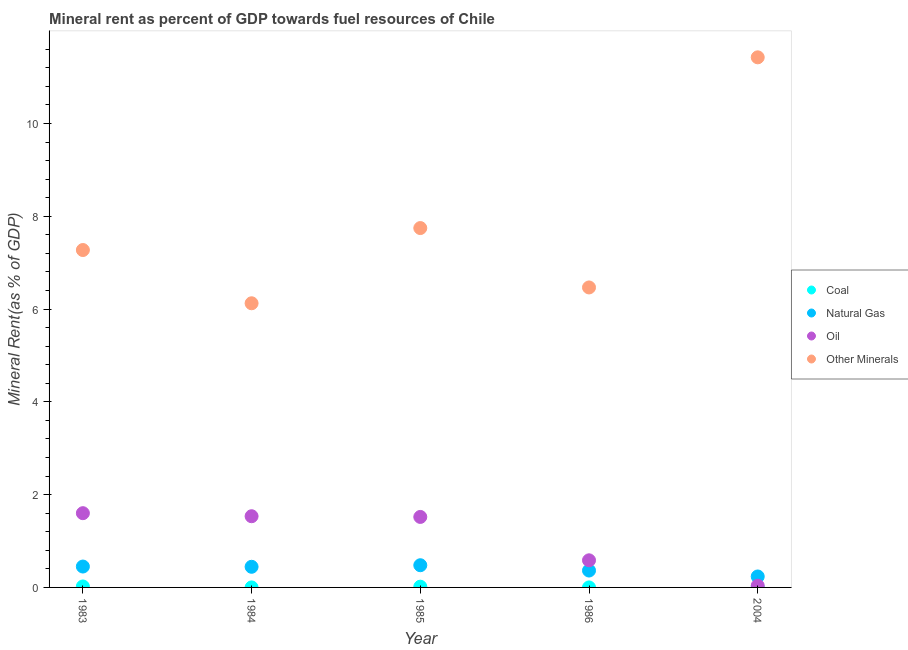What is the  rent of other minerals in 1984?
Your response must be concise. 6.12. Across all years, what is the maximum oil rent?
Offer a terse response. 1.6. Across all years, what is the minimum natural gas rent?
Your answer should be very brief. 0.24. In which year was the coal rent minimum?
Your answer should be very brief. 1986. What is the total oil rent in the graph?
Your answer should be very brief. 5.28. What is the difference between the natural gas rent in 1983 and that in 1985?
Your answer should be compact. -0.03. What is the difference between the oil rent in 1986 and the natural gas rent in 1984?
Make the answer very short. 0.14. What is the average oil rent per year?
Provide a succinct answer. 1.06. In the year 2004, what is the difference between the oil rent and coal rent?
Make the answer very short. 0.04. In how many years, is the  rent of other minerals greater than 10.4 %?
Ensure brevity in your answer.  1. What is the ratio of the oil rent in 1984 to that in 1986?
Your response must be concise. 2.63. Is the difference between the  rent of other minerals in 1983 and 1985 greater than the difference between the oil rent in 1983 and 1985?
Ensure brevity in your answer.  No. What is the difference between the highest and the second highest natural gas rent?
Your answer should be compact. 0.03. What is the difference between the highest and the lowest natural gas rent?
Give a very brief answer. 0.24. In how many years, is the oil rent greater than the average oil rent taken over all years?
Offer a very short reply. 3. Is the sum of the  rent of other minerals in 1985 and 1986 greater than the maximum coal rent across all years?
Provide a succinct answer. Yes. Is it the case that in every year, the sum of the  rent of other minerals and oil rent is greater than the sum of coal rent and natural gas rent?
Provide a succinct answer. Yes. Is it the case that in every year, the sum of the coal rent and natural gas rent is greater than the oil rent?
Ensure brevity in your answer.  No. Does the natural gas rent monotonically increase over the years?
Make the answer very short. No. Is the coal rent strictly less than the  rent of other minerals over the years?
Keep it short and to the point. Yes. How many years are there in the graph?
Keep it short and to the point. 5. What is the difference between two consecutive major ticks on the Y-axis?
Give a very brief answer. 2. How many legend labels are there?
Offer a very short reply. 4. What is the title of the graph?
Your answer should be compact. Mineral rent as percent of GDP towards fuel resources of Chile. Does "Quality of logistic services" appear as one of the legend labels in the graph?
Give a very brief answer. No. What is the label or title of the Y-axis?
Your response must be concise. Mineral Rent(as % of GDP). What is the Mineral Rent(as % of GDP) in Coal in 1983?
Provide a succinct answer. 0.02. What is the Mineral Rent(as % of GDP) of Natural Gas in 1983?
Your answer should be compact. 0.45. What is the Mineral Rent(as % of GDP) of Oil in 1983?
Offer a terse response. 1.6. What is the Mineral Rent(as % of GDP) in Other Minerals in 1983?
Your answer should be very brief. 7.27. What is the Mineral Rent(as % of GDP) of Coal in 1984?
Ensure brevity in your answer.  0. What is the Mineral Rent(as % of GDP) in Natural Gas in 1984?
Your answer should be compact. 0.44. What is the Mineral Rent(as % of GDP) of Oil in 1984?
Offer a terse response. 1.53. What is the Mineral Rent(as % of GDP) of Other Minerals in 1984?
Offer a very short reply. 6.12. What is the Mineral Rent(as % of GDP) in Coal in 1985?
Your response must be concise. 0.02. What is the Mineral Rent(as % of GDP) in Natural Gas in 1985?
Give a very brief answer. 0.48. What is the Mineral Rent(as % of GDP) of Oil in 1985?
Your answer should be compact. 1.52. What is the Mineral Rent(as % of GDP) of Other Minerals in 1985?
Offer a very short reply. 7.75. What is the Mineral Rent(as % of GDP) of Coal in 1986?
Provide a short and direct response. 0. What is the Mineral Rent(as % of GDP) in Natural Gas in 1986?
Your answer should be very brief. 0.36. What is the Mineral Rent(as % of GDP) of Oil in 1986?
Provide a succinct answer. 0.58. What is the Mineral Rent(as % of GDP) of Other Minerals in 1986?
Your answer should be very brief. 6.47. What is the Mineral Rent(as % of GDP) of Coal in 2004?
Offer a terse response. 0. What is the Mineral Rent(as % of GDP) of Natural Gas in 2004?
Your answer should be compact. 0.24. What is the Mineral Rent(as % of GDP) of Oil in 2004?
Give a very brief answer. 0.04. What is the Mineral Rent(as % of GDP) of Other Minerals in 2004?
Your answer should be very brief. 11.43. Across all years, what is the maximum Mineral Rent(as % of GDP) of Coal?
Offer a very short reply. 0.02. Across all years, what is the maximum Mineral Rent(as % of GDP) in Natural Gas?
Your answer should be very brief. 0.48. Across all years, what is the maximum Mineral Rent(as % of GDP) in Oil?
Provide a succinct answer. 1.6. Across all years, what is the maximum Mineral Rent(as % of GDP) in Other Minerals?
Make the answer very short. 11.43. Across all years, what is the minimum Mineral Rent(as % of GDP) in Coal?
Your answer should be compact. 0. Across all years, what is the minimum Mineral Rent(as % of GDP) of Natural Gas?
Keep it short and to the point. 0.24. Across all years, what is the minimum Mineral Rent(as % of GDP) in Oil?
Give a very brief answer. 0.04. Across all years, what is the minimum Mineral Rent(as % of GDP) in Other Minerals?
Make the answer very short. 6.12. What is the total Mineral Rent(as % of GDP) in Coal in the graph?
Give a very brief answer. 0.04. What is the total Mineral Rent(as % of GDP) of Natural Gas in the graph?
Offer a very short reply. 1.97. What is the total Mineral Rent(as % of GDP) in Oil in the graph?
Your response must be concise. 5.28. What is the total Mineral Rent(as % of GDP) in Other Minerals in the graph?
Offer a very short reply. 39.04. What is the difference between the Mineral Rent(as % of GDP) in Coal in 1983 and that in 1984?
Provide a succinct answer. 0.02. What is the difference between the Mineral Rent(as % of GDP) in Natural Gas in 1983 and that in 1984?
Make the answer very short. 0.01. What is the difference between the Mineral Rent(as % of GDP) of Oil in 1983 and that in 1984?
Your response must be concise. 0.07. What is the difference between the Mineral Rent(as % of GDP) in Other Minerals in 1983 and that in 1984?
Provide a succinct answer. 1.15. What is the difference between the Mineral Rent(as % of GDP) in Coal in 1983 and that in 1985?
Make the answer very short. 0. What is the difference between the Mineral Rent(as % of GDP) in Natural Gas in 1983 and that in 1985?
Make the answer very short. -0.03. What is the difference between the Mineral Rent(as % of GDP) in Oil in 1983 and that in 1985?
Offer a very short reply. 0.08. What is the difference between the Mineral Rent(as % of GDP) of Other Minerals in 1983 and that in 1985?
Keep it short and to the point. -0.47. What is the difference between the Mineral Rent(as % of GDP) in Coal in 1983 and that in 1986?
Make the answer very short. 0.02. What is the difference between the Mineral Rent(as % of GDP) of Natural Gas in 1983 and that in 1986?
Your answer should be very brief. 0.09. What is the difference between the Mineral Rent(as % of GDP) of Oil in 1983 and that in 1986?
Offer a terse response. 1.02. What is the difference between the Mineral Rent(as % of GDP) of Other Minerals in 1983 and that in 1986?
Ensure brevity in your answer.  0.81. What is the difference between the Mineral Rent(as % of GDP) in Coal in 1983 and that in 2004?
Provide a short and direct response. 0.02. What is the difference between the Mineral Rent(as % of GDP) of Natural Gas in 1983 and that in 2004?
Make the answer very short. 0.21. What is the difference between the Mineral Rent(as % of GDP) of Oil in 1983 and that in 2004?
Offer a very short reply. 1.56. What is the difference between the Mineral Rent(as % of GDP) of Other Minerals in 1983 and that in 2004?
Provide a short and direct response. -4.15. What is the difference between the Mineral Rent(as % of GDP) in Coal in 1984 and that in 1985?
Offer a very short reply. -0.02. What is the difference between the Mineral Rent(as % of GDP) in Natural Gas in 1984 and that in 1985?
Offer a very short reply. -0.03. What is the difference between the Mineral Rent(as % of GDP) in Oil in 1984 and that in 1985?
Make the answer very short. 0.01. What is the difference between the Mineral Rent(as % of GDP) of Other Minerals in 1984 and that in 1985?
Give a very brief answer. -1.62. What is the difference between the Mineral Rent(as % of GDP) of Coal in 1984 and that in 1986?
Offer a very short reply. 0. What is the difference between the Mineral Rent(as % of GDP) of Natural Gas in 1984 and that in 1986?
Offer a very short reply. 0.08. What is the difference between the Mineral Rent(as % of GDP) in Oil in 1984 and that in 1986?
Your response must be concise. 0.95. What is the difference between the Mineral Rent(as % of GDP) in Other Minerals in 1984 and that in 1986?
Your answer should be compact. -0.34. What is the difference between the Mineral Rent(as % of GDP) of Coal in 1984 and that in 2004?
Provide a short and direct response. -0. What is the difference between the Mineral Rent(as % of GDP) of Natural Gas in 1984 and that in 2004?
Your answer should be compact. 0.21. What is the difference between the Mineral Rent(as % of GDP) of Oil in 1984 and that in 2004?
Keep it short and to the point. 1.5. What is the difference between the Mineral Rent(as % of GDP) of Other Minerals in 1984 and that in 2004?
Your answer should be very brief. -5.3. What is the difference between the Mineral Rent(as % of GDP) in Coal in 1985 and that in 1986?
Keep it short and to the point. 0.02. What is the difference between the Mineral Rent(as % of GDP) in Natural Gas in 1985 and that in 1986?
Give a very brief answer. 0.11. What is the difference between the Mineral Rent(as % of GDP) in Oil in 1985 and that in 1986?
Your response must be concise. 0.94. What is the difference between the Mineral Rent(as % of GDP) of Other Minerals in 1985 and that in 1986?
Keep it short and to the point. 1.28. What is the difference between the Mineral Rent(as % of GDP) in Coal in 1985 and that in 2004?
Provide a succinct answer. 0.01. What is the difference between the Mineral Rent(as % of GDP) in Natural Gas in 1985 and that in 2004?
Your answer should be very brief. 0.24. What is the difference between the Mineral Rent(as % of GDP) in Oil in 1985 and that in 2004?
Offer a very short reply. 1.48. What is the difference between the Mineral Rent(as % of GDP) in Other Minerals in 1985 and that in 2004?
Your answer should be very brief. -3.68. What is the difference between the Mineral Rent(as % of GDP) of Coal in 1986 and that in 2004?
Your response must be concise. -0. What is the difference between the Mineral Rent(as % of GDP) of Natural Gas in 1986 and that in 2004?
Your response must be concise. 0.13. What is the difference between the Mineral Rent(as % of GDP) of Oil in 1986 and that in 2004?
Provide a succinct answer. 0.55. What is the difference between the Mineral Rent(as % of GDP) in Other Minerals in 1986 and that in 2004?
Give a very brief answer. -4.96. What is the difference between the Mineral Rent(as % of GDP) in Coal in 1983 and the Mineral Rent(as % of GDP) in Natural Gas in 1984?
Ensure brevity in your answer.  -0.42. What is the difference between the Mineral Rent(as % of GDP) in Coal in 1983 and the Mineral Rent(as % of GDP) in Oil in 1984?
Ensure brevity in your answer.  -1.51. What is the difference between the Mineral Rent(as % of GDP) of Coal in 1983 and the Mineral Rent(as % of GDP) of Other Minerals in 1984?
Offer a terse response. -6.1. What is the difference between the Mineral Rent(as % of GDP) in Natural Gas in 1983 and the Mineral Rent(as % of GDP) in Oil in 1984?
Your answer should be very brief. -1.08. What is the difference between the Mineral Rent(as % of GDP) in Natural Gas in 1983 and the Mineral Rent(as % of GDP) in Other Minerals in 1984?
Keep it short and to the point. -5.67. What is the difference between the Mineral Rent(as % of GDP) of Oil in 1983 and the Mineral Rent(as % of GDP) of Other Minerals in 1984?
Provide a succinct answer. -4.52. What is the difference between the Mineral Rent(as % of GDP) in Coal in 1983 and the Mineral Rent(as % of GDP) in Natural Gas in 1985?
Offer a terse response. -0.46. What is the difference between the Mineral Rent(as % of GDP) of Coal in 1983 and the Mineral Rent(as % of GDP) of Oil in 1985?
Make the answer very short. -1.5. What is the difference between the Mineral Rent(as % of GDP) in Coal in 1983 and the Mineral Rent(as % of GDP) in Other Minerals in 1985?
Give a very brief answer. -7.73. What is the difference between the Mineral Rent(as % of GDP) of Natural Gas in 1983 and the Mineral Rent(as % of GDP) of Oil in 1985?
Make the answer very short. -1.07. What is the difference between the Mineral Rent(as % of GDP) of Natural Gas in 1983 and the Mineral Rent(as % of GDP) of Other Minerals in 1985?
Offer a very short reply. -7.3. What is the difference between the Mineral Rent(as % of GDP) of Oil in 1983 and the Mineral Rent(as % of GDP) of Other Minerals in 1985?
Keep it short and to the point. -6.15. What is the difference between the Mineral Rent(as % of GDP) of Coal in 1983 and the Mineral Rent(as % of GDP) of Natural Gas in 1986?
Ensure brevity in your answer.  -0.34. What is the difference between the Mineral Rent(as % of GDP) in Coal in 1983 and the Mineral Rent(as % of GDP) in Oil in 1986?
Offer a terse response. -0.56. What is the difference between the Mineral Rent(as % of GDP) in Coal in 1983 and the Mineral Rent(as % of GDP) in Other Minerals in 1986?
Give a very brief answer. -6.45. What is the difference between the Mineral Rent(as % of GDP) of Natural Gas in 1983 and the Mineral Rent(as % of GDP) of Oil in 1986?
Your answer should be very brief. -0.13. What is the difference between the Mineral Rent(as % of GDP) of Natural Gas in 1983 and the Mineral Rent(as % of GDP) of Other Minerals in 1986?
Your answer should be compact. -6.02. What is the difference between the Mineral Rent(as % of GDP) of Oil in 1983 and the Mineral Rent(as % of GDP) of Other Minerals in 1986?
Provide a succinct answer. -4.87. What is the difference between the Mineral Rent(as % of GDP) of Coal in 1983 and the Mineral Rent(as % of GDP) of Natural Gas in 2004?
Your response must be concise. -0.22. What is the difference between the Mineral Rent(as % of GDP) in Coal in 1983 and the Mineral Rent(as % of GDP) in Oil in 2004?
Keep it short and to the point. -0.02. What is the difference between the Mineral Rent(as % of GDP) of Coal in 1983 and the Mineral Rent(as % of GDP) of Other Minerals in 2004?
Give a very brief answer. -11.41. What is the difference between the Mineral Rent(as % of GDP) of Natural Gas in 1983 and the Mineral Rent(as % of GDP) of Oil in 2004?
Make the answer very short. 0.41. What is the difference between the Mineral Rent(as % of GDP) of Natural Gas in 1983 and the Mineral Rent(as % of GDP) of Other Minerals in 2004?
Make the answer very short. -10.98. What is the difference between the Mineral Rent(as % of GDP) of Oil in 1983 and the Mineral Rent(as % of GDP) of Other Minerals in 2004?
Your answer should be very brief. -9.83. What is the difference between the Mineral Rent(as % of GDP) in Coal in 1984 and the Mineral Rent(as % of GDP) in Natural Gas in 1985?
Give a very brief answer. -0.48. What is the difference between the Mineral Rent(as % of GDP) in Coal in 1984 and the Mineral Rent(as % of GDP) in Oil in 1985?
Make the answer very short. -1.52. What is the difference between the Mineral Rent(as % of GDP) in Coal in 1984 and the Mineral Rent(as % of GDP) in Other Minerals in 1985?
Offer a very short reply. -7.75. What is the difference between the Mineral Rent(as % of GDP) of Natural Gas in 1984 and the Mineral Rent(as % of GDP) of Oil in 1985?
Your response must be concise. -1.07. What is the difference between the Mineral Rent(as % of GDP) of Natural Gas in 1984 and the Mineral Rent(as % of GDP) of Other Minerals in 1985?
Your answer should be compact. -7.3. What is the difference between the Mineral Rent(as % of GDP) of Oil in 1984 and the Mineral Rent(as % of GDP) of Other Minerals in 1985?
Offer a terse response. -6.21. What is the difference between the Mineral Rent(as % of GDP) in Coal in 1984 and the Mineral Rent(as % of GDP) in Natural Gas in 1986?
Provide a succinct answer. -0.36. What is the difference between the Mineral Rent(as % of GDP) of Coal in 1984 and the Mineral Rent(as % of GDP) of Oil in 1986?
Your response must be concise. -0.58. What is the difference between the Mineral Rent(as % of GDP) of Coal in 1984 and the Mineral Rent(as % of GDP) of Other Minerals in 1986?
Your answer should be very brief. -6.47. What is the difference between the Mineral Rent(as % of GDP) in Natural Gas in 1984 and the Mineral Rent(as % of GDP) in Oil in 1986?
Offer a terse response. -0.14. What is the difference between the Mineral Rent(as % of GDP) of Natural Gas in 1984 and the Mineral Rent(as % of GDP) of Other Minerals in 1986?
Offer a terse response. -6.02. What is the difference between the Mineral Rent(as % of GDP) of Oil in 1984 and the Mineral Rent(as % of GDP) of Other Minerals in 1986?
Offer a very short reply. -4.93. What is the difference between the Mineral Rent(as % of GDP) of Coal in 1984 and the Mineral Rent(as % of GDP) of Natural Gas in 2004?
Offer a very short reply. -0.24. What is the difference between the Mineral Rent(as % of GDP) of Coal in 1984 and the Mineral Rent(as % of GDP) of Oil in 2004?
Provide a succinct answer. -0.04. What is the difference between the Mineral Rent(as % of GDP) of Coal in 1984 and the Mineral Rent(as % of GDP) of Other Minerals in 2004?
Provide a succinct answer. -11.43. What is the difference between the Mineral Rent(as % of GDP) in Natural Gas in 1984 and the Mineral Rent(as % of GDP) in Oil in 2004?
Keep it short and to the point. 0.41. What is the difference between the Mineral Rent(as % of GDP) of Natural Gas in 1984 and the Mineral Rent(as % of GDP) of Other Minerals in 2004?
Keep it short and to the point. -10.98. What is the difference between the Mineral Rent(as % of GDP) of Oil in 1984 and the Mineral Rent(as % of GDP) of Other Minerals in 2004?
Offer a very short reply. -9.89. What is the difference between the Mineral Rent(as % of GDP) in Coal in 1985 and the Mineral Rent(as % of GDP) in Natural Gas in 1986?
Offer a terse response. -0.35. What is the difference between the Mineral Rent(as % of GDP) of Coal in 1985 and the Mineral Rent(as % of GDP) of Oil in 1986?
Make the answer very short. -0.57. What is the difference between the Mineral Rent(as % of GDP) in Coal in 1985 and the Mineral Rent(as % of GDP) in Other Minerals in 1986?
Your response must be concise. -6.45. What is the difference between the Mineral Rent(as % of GDP) in Natural Gas in 1985 and the Mineral Rent(as % of GDP) in Oil in 1986?
Your answer should be compact. -0.11. What is the difference between the Mineral Rent(as % of GDP) in Natural Gas in 1985 and the Mineral Rent(as % of GDP) in Other Minerals in 1986?
Your answer should be compact. -5.99. What is the difference between the Mineral Rent(as % of GDP) in Oil in 1985 and the Mineral Rent(as % of GDP) in Other Minerals in 1986?
Keep it short and to the point. -4.95. What is the difference between the Mineral Rent(as % of GDP) in Coal in 1985 and the Mineral Rent(as % of GDP) in Natural Gas in 2004?
Offer a very short reply. -0.22. What is the difference between the Mineral Rent(as % of GDP) in Coal in 1985 and the Mineral Rent(as % of GDP) in Oil in 2004?
Make the answer very short. -0.02. What is the difference between the Mineral Rent(as % of GDP) in Coal in 1985 and the Mineral Rent(as % of GDP) in Other Minerals in 2004?
Offer a terse response. -11.41. What is the difference between the Mineral Rent(as % of GDP) in Natural Gas in 1985 and the Mineral Rent(as % of GDP) in Oil in 2004?
Make the answer very short. 0.44. What is the difference between the Mineral Rent(as % of GDP) of Natural Gas in 1985 and the Mineral Rent(as % of GDP) of Other Minerals in 2004?
Provide a succinct answer. -10.95. What is the difference between the Mineral Rent(as % of GDP) of Oil in 1985 and the Mineral Rent(as % of GDP) of Other Minerals in 2004?
Provide a succinct answer. -9.91. What is the difference between the Mineral Rent(as % of GDP) of Coal in 1986 and the Mineral Rent(as % of GDP) of Natural Gas in 2004?
Offer a very short reply. -0.24. What is the difference between the Mineral Rent(as % of GDP) of Coal in 1986 and the Mineral Rent(as % of GDP) of Oil in 2004?
Provide a short and direct response. -0.04. What is the difference between the Mineral Rent(as % of GDP) of Coal in 1986 and the Mineral Rent(as % of GDP) of Other Minerals in 2004?
Keep it short and to the point. -11.43. What is the difference between the Mineral Rent(as % of GDP) of Natural Gas in 1986 and the Mineral Rent(as % of GDP) of Oil in 2004?
Ensure brevity in your answer.  0.33. What is the difference between the Mineral Rent(as % of GDP) in Natural Gas in 1986 and the Mineral Rent(as % of GDP) in Other Minerals in 2004?
Provide a short and direct response. -11.06. What is the difference between the Mineral Rent(as % of GDP) of Oil in 1986 and the Mineral Rent(as % of GDP) of Other Minerals in 2004?
Give a very brief answer. -10.84. What is the average Mineral Rent(as % of GDP) of Coal per year?
Make the answer very short. 0.01. What is the average Mineral Rent(as % of GDP) in Natural Gas per year?
Offer a terse response. 0.39. What is the average Mineral Rent(as % of GDP) of Oil per year?
Your answer should be very brief. 1.06. What is the average Mineral Rent(as % of GDP) in Other Minerals per year?
Give a very brief answer. 7.81. In the year 1983, what is the difference between the Mineral Rent(as % of GDP) in Coal and Mineral Rent(as % of GDP) in Natural Gas?
Provide a succinct answer. -0.43. In the year 1983, what is the difference between the Mineral Rent(as % of GDP) in Coal and Mineral Rent(as % of GDP) in Oil?
Keep it short and to the point. -1.58. In the year 1983, what is the difference between the Mineral Rent(as % of GDP) of Coal and Mineral Rent(as % of GDP) of Other Minerals?
Your answer should be very brief. -7.25. In the year 1983, what is the difference between the Mineral Rent(as % of GDP) of Natural Gas and Mineral Rent(as % of GDP) of Oil?
Your answer should be very brief. -1.15. In the year 1983, what is the difference between the Mineral Rent(as % of GDP) in Natural Gas and Mineral Rent(as % of GDP) in Other Minerals?
Offer a very short reply. -6.82. In the year 1983, what is the difference between the Mineral Rent(as % of GDP) of Oil and Mineral Rent(as % of GDP) of Other Minerals?
Your response must be concise. -5.67. In the year 1984, what is the difference between the Mineral Rent(as % of GDP) in Coal and Mineral Rent(as % of GDP) in Natural Gas?
Provide a short and direct response. -0.44. In the year 1984, what is the difference between the Mineral Rent(as % of GDP) in Coal and Mineral Rent(as % of GDP) in Oil?
Keep it short and to the point. -1.53. In the year 1984, what is the difference between the Mineral Rent(as % of GDP) in Coal and Mineral Rent(as % of GDP) in Other Minerals?
Ensure brevity in your answer.  -6.12. In the year 1984, what is the difference between the Mineral Rent(as % of GDP) in Natural Gas and Mineral Rent(as % of GDP) in Oil?
Offer a very short reply. -1.09. In the year 1984, what is the difference between the Mineral Rent(as % of GDP) of Natural Gas and Mineral Rent(as % of GDP) of Other Minerals?
Keep it short and to the point. -5.68. In the year 1984, what is the difference between the Mineral Rent(as % of GDP) in Oil and Mineral Rent(as % of GDP) in Other Minerals?
Offer a very short reply. -4.59. In the year 1985, what is the difference between the Mineral Rent(as % of GDP) in Coal and Mineral Rent(as % of GDP) in Natural Gas?
Your answer should be compact. -0.46. In the year 1985, what is the difference between the Mineral Rent(as % of GDP) in Coal and Mineral Rent(as % of GDP) in Oil?
Provide a short and direct response. -1.5. In the year 1985, what is the difference between the Mineral Rent(as % of GDP) of Coal and Mineral Rent(as % of GDP) of Other Minerals?
Keep it short and to the point. -7.73. In the year 1985, what is the difference between the Mineral Rent(as % of GDP) in Natural Gas and Mineral Rent(as % of GDP) in Oil?
Ensure brevity in your answer.  -1.04. In the year 1985, what is the difference between the Mineral Rent(as % of GDP) in Natural Gas and Mineral Rent(as % of GDP) in Other Minerals?
Provide a succinct answer. -7.27. In the year 1985, what is the difference between the Mineral Rent(as % of GDP) in Oil and Mineral Rent(as % of GDP) in Other Minerals?
Ensure brevity in your answer.  -6.23. In the year 1986, what is the difference between the Mineral Rent(as % of GDP) in Coal and Mineral Rent(as % of GDP) in Natural Gas?
Offer a very short reply. -0.36. In the year 1986, what is the difference between the Mineral Rent(as % of GDP) in Coal and Mineral Rent(as % of GDP) in Oil?
Provide a short and direct response. -0.58. In the year 1986, what is the difference between the Mineral Rent(as % of GDP) of Coal and Mineral Rent(as % of GDP) of Other Minerals?
Offer a very short reply. -6.47. In the year 1986, what is the difference between the Mineral Rent(as % of GDP) in Natural Gas and Mineral Rent(as % of GDP) in Oil?
Your answer should be very brief. -0.22. In the year 1986, what is the difference between the Mineral Rent(as % of GDP) in Natural Gas and Mineral Rent(as % of GDP) in Other Minerals?
Offer a terse response. -6.1. In the year 1986, what is the difference between the Mineral Rent(as % of GDP) in Oil and Mineral Rent(as % of GDP) in Other Minerals?
Provide a short and direct response. -5.88. In the year 2004, what is the difference between the Mineral Rent(as % of GDP) of Coal and Mineral Rent(as % of GDP) of Natural Gas?
Offer a terse response. -0.23. In the year 2004, what is the difference between the Mineral Rent(as % of GDP) of Coal and Mineral Rent(as % of GDP) of Oil?
Your answer should be very brief. -0.04. In the year 2004, what is the difference between the Mineral Rent(as % of GDP) of Coal and Mineral Rent(as % of GDP) of Other Minerals?
Ensure brevity in your answer.  -11.42. In the year 2004, what is the difference between the Mineral Rent(as % of GDP) of Natural Gas and Mineral Rent(as % of GDP) of Oil?
Offer a very short reply. 0.2. In the year 2004, what is the difference between the Mineral Rent(as % of GDP) of Natural Gas and Mineral Rent(as % of GDP) of Other Minerals?
Your answer should be compact. -11.19. In the year 2004, what is the difference between the Mineral Rent(as % of GDP) of Oil and Mineral Rent(as % of GDP) of Other Minerals?
Offer a very short reply. -11.39. What is the ratio of the Mineral Rent(as % of GDP) of Coal in 1983 to that in 1984?
Your response must be concise. 55.14. What is the ratio of the Mineral Rent(as % of GDP) of Natural Gas in 1983 to that in 1984?
Make the answer very short. 1.01. What is the ratio of the Mineral Rent(as % of GDP) of Oil in 1983 to that in 1984?
Offer a very short reply. 1.04. What is the ratio of the Mineral Rent(as % of GDP) of Other Minerals in 1983 to that in 1984?
Offer a very short reply. 1.19. What is the ratio of the Mineral Rent(as % of GDP) in Coal in 1983 to that in 1985?
Keep it short and to the point. 1.3. What is the ratio of the Mineral Rent(as % of GDP) of Natural Gas in 1983 to that in 1985?
Ensure brevity in your answer.  0.94. What is the ratio of the Mineral Rent(as % of GDP) of Oil in 1983 to that in 1985?
Make the answer very short. 1.05. What is the ratio of the Mineral Rent(as % of GDP) in Other Minerals in 1983 to that in 1985?
Your answer should be compact. 0.94. What is the ratio of the Mineral Rent(as % of GDP) of Coal in 1983 to that in 1986?
Give a very brief answer. 161.06. What is the ratio of the Mineral Rent(as % of GDP) in Natural Gas in 1983 to that in 1986?
Offer a very short reply. 1.24. What is the ratio of the Mineral Rent(as % of GDP) of Oil in 1983 to that in 1986?
Your answer should be compact. 2.74. What is the ratio of the Mineral Rent(as % of GDP) in Other Minerals in 1983 to that in 1986?
Offer a terse response. 1.12. What is the ratio of the Mineral Rent(as % of GDP) of Coal in 1983 to that in 2004?
Ensure brevity in your answer.  9.14. What is the ratio of the Mineral Rent(as % of GDP) of Natural Gas in 1983 to that in 2004?
Provide a succinct answer. 1.91. What is the ratio of the Mineral Rent(as % of GDP) in Oil in 1983 to that in 2004?
Ensure brevity in your answer.  42.86. What is the ratio of the Mineral Rent(as % of GDP) of Other Minerals in 1983 to that in 2004?
Your response must be concise. 0.64. What is the ratio of the Mineral Rent(as % of GDP) of Coal in 1984 to that in 1985?
Offer a terse response. 0.02. What is the ratio of the Mineral Rent(as % of GDP) of Natural Gas in 1984 to that in 1985?
Offer a terse response. 0.93. What is the ratio of the Mineral Rent(as % of GDP) of Oil in 1984 to that in 1985?
Make the answer very short. 1.01. What is the ratio of the Mineral Rent(as % of GDP) in Other Minerals in 1984 to that in 1985?
Provide a short and direct response. 0.79. What is the ratio of the Mineral Rent(as % of GDP) of Coal in 1984 to that in 1986?
Offer a terse response. 2.92. What is the ratio of the Mineral Rent(as % of GDP) of Natural Gas in 1984 to that in 1986?
Give a very brief answer. 1.22. What is the ratio of the Mineral Rent(as % of GDP) of Oil in 1984 to that in 1986?
Provide a succinct answer. 2.63. What is the ratio of the Mineral Rent(as % of GDP) of Other Minerals in 1984 to that in 1986?
Your response must be concise. 0.95. What is the ratio of the Mineral Rent(as % of GDP) in Coal in 1984 to that in 2004?
Offer a very short reply. 0.17. What is the ratio of the Mineral Rent(as % of GDP) in Natural Gas in 1984 to that in 2004?
Your response must be concise. 1.88. What is the ratio of the Mineral Rent(as % of GDP) in Oil in 1984 to that in 2004?
Provide a short and direct response. 41.1. What is the ratio of the Mineral Rent(as % of GDP) of Other Minerals in 1984 to that in 2004?
Your response must be concise. 0.54. What is the ratio of the Mineral Rent(as % of GDP) of Coal in 1985 to that in 1986?
Offer a terse response. 124.09. What is the ratio of the Mineral Rent(as % of GDP) in Natural Gas in 1985 to that in 1986?
Keep it short and to the point. 1.31. What is the ratio of the Mineral Rent(as % of GDP) in Oil in 1985 to that in 1986?
Make the answer very short. 2.6. What is the ratio of the Mineral Rent(as % of GDP) in Other Minerals in 1985 to that in 1986?
Your answer should be very brief. 1.2. What is the ratio of the Mineral Rent(as % of GDP) in Coal in 1985 to that in 2004?
Make the answer very short. 7.05. What is the ratio of the Mineral Rent(as % of GDP) in Natural Gas in 1985 to that in 2004?
Your answer should be very brief. 2.03. What is the ratio of the Mineral Rent(as % of GDP) of Oil in 1985 to that in 2004?
Make the answer very short. 40.7. What is the ratio of the Mineral Rent(as % of GDP) of Other Minerals in 1985 to that in 2004?
Your response must be concise. 0.68. What is the ratio of the Mineral Rent(as % of GDP) of Coal in 1986 to that in 2004?
Your answer should be compact. 0.06. What is the ratio of the Mineral Rent(as % of GDP) in Natural Gas in 1986 to that in 2004?
Offer a terse response. 1.54. What is the ratio of the Mineral Rent(as % of GDP) in Oil in 1986 to that in 2004?
Your response must be concise. 15.66. What is the ratio of the Mineral Rent(as % of GDP) of Other Minerals in 1986 to that in 2004?
Your response must be concise. 0.57. What is the difference between the highest and the second highest Mineral Rent(as % of GDP) of Coal?
Make the answer very short. 0. What is the difference between the highest and the second highest Mineral Rent(as % of GDP) in Natural Gas?
Give a very brief answer. 0.03. What is the difference between the highest and the second highest Mineral Rent(as % of GDP) in Oil?
Your answer should be compact. 0.07. What is the difference between the highest and the second highest Mineral Rent(as % of GDP) in Other Minerals?
Give a very brief answer. 3.68. What is the difference between the highest and the lowest Mineral Rent(as % of GDP) in Coal?
Provide a short and direct response. 0.02. What is the difference between the highest and the lowest Mineral Rent(as % of GDP) of Natural Gas?
Your response must be concise. 0.24. What is the difference between the highest and the lowest Mineral Rent(as % of GDP) of Oil?
Keep it short and to the point. 1.56. What is the difference between the highest and the lowest Mineral Rent(as % of GDP) in Other Minerals?
Keep it short and to the point. 5.3. 